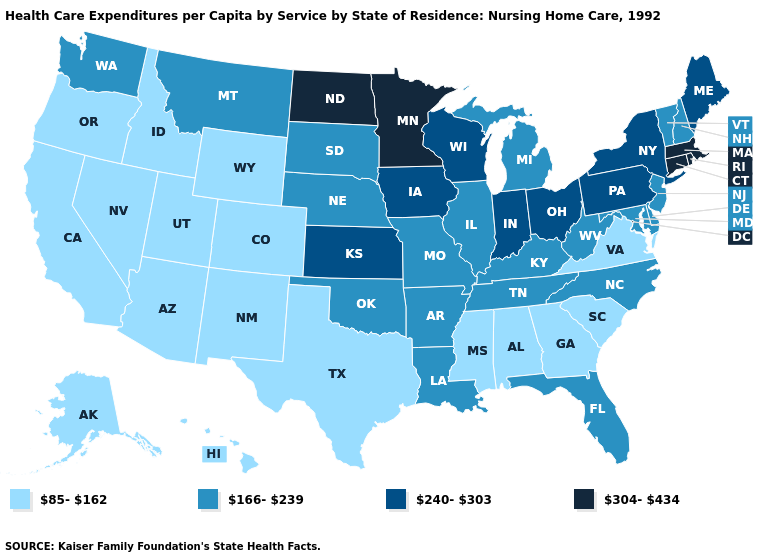Name the states that have a value in the range 240-303?
Quick response, please. Indiana, Iowa, Kansas, Maine, New York, Ohio, Pennsylvania, Wisconsin. Does Minnesota have the same value as Connecticut?
Short answer required. Yes. What is the lowest value in states that border North Dakota?
Concise answer only. 166-239. What is the lowest value in the Northeast?
Write a very short answer. 166-239. Does the map have missing data?
Keep it brief. No. Among the states that border Delaware , does Pennsylvania have the highest value?
Keep it brief. Yes. What is the value of New Mexico?
Quick response, please. 85-162. What is the lowest value in the South?
Quick response, please. 85-162. Name the states that have a value in the range 304-434?
Answer briefly. Connecticut, Massachusetts, Minnesota, North Dakota, Rhode Island. What is the lowest value in states that border South Carolina?
Keep it brief. 85-162. Which states have the lowest value in the USA?
Concise answer only. Alabama, Alaska, Arizona, California, Colorado, Georgia, Hawaii, Idaho, Mississippi, Nevada, New Mexico, Oregon, South Carolina, Texas, Utah, Virginia, Wyoming. Does Maine have a higher value than Ohio?
Be succinct. No. Name the states that have a value in the range 304-434?
Write a very short answer. Connecticut, Massachusetts, Minnesota, North Dakota, Rhode Island. Name the states that have a value in the range 166-239?
Write a very short answer. Arkansas, Delaware, Florida, Illinois, Kentucky, Louisiana, Maryland, Michigan, Missouri, Montana, Nebraska, New Hampshire, New Jersey, North Carolina, Oklahoma, South Dakota, Tennessee, Vermont, Washington, West Virginia. Name the states that have a value in the range 304-434?
Write a very short answer. Connecticut, Massachusetts, Minnesota, North Dakota, Rhode Island. 